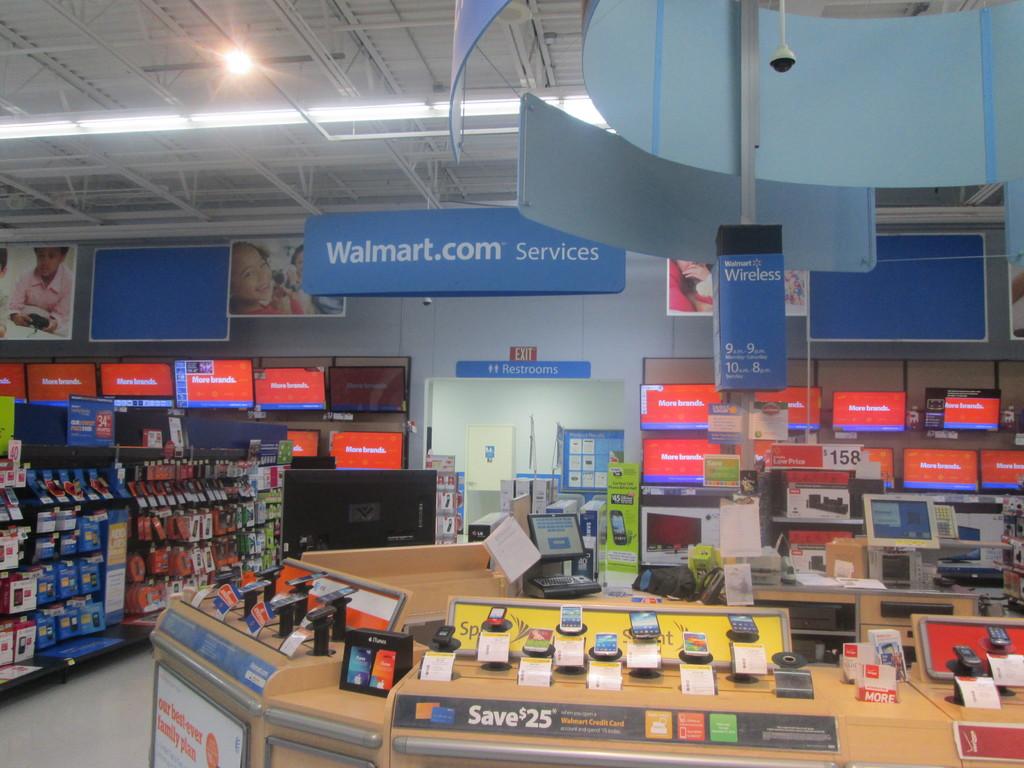How much will you save?
Offer a very short reply. $25. What store is this?
Offer a very short reply. Walmart. 